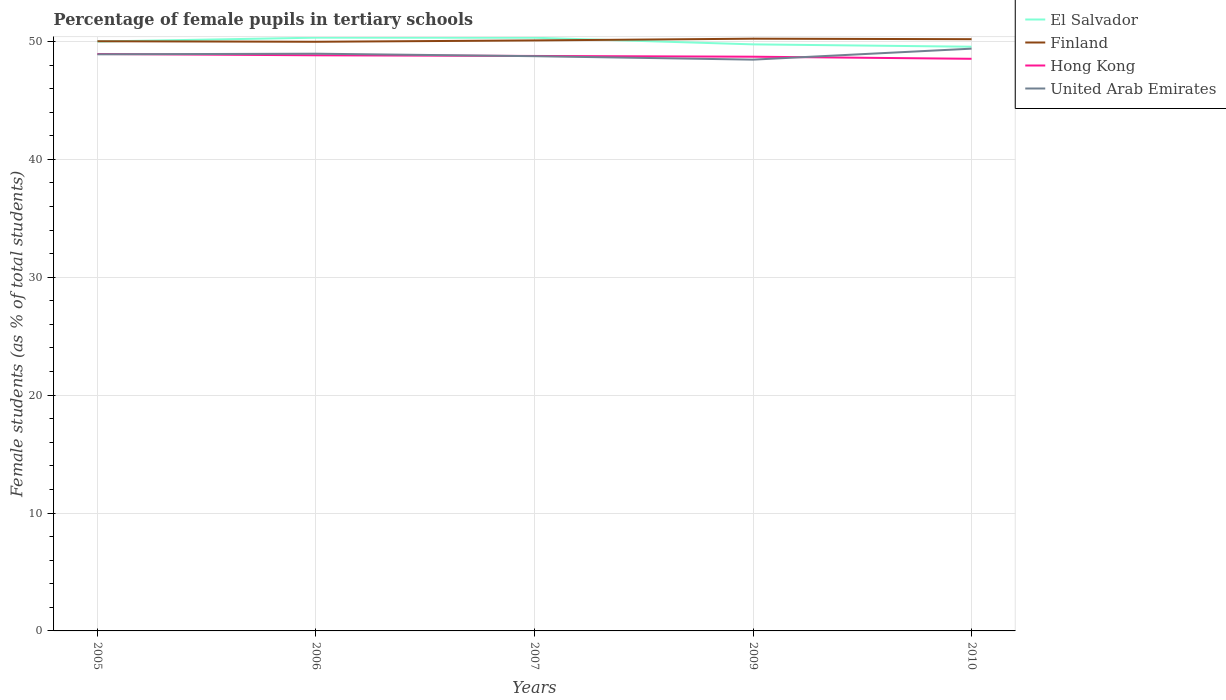Is the number of lines equal to the number of legend labels?
Offer a very short reply. Yes. Across all years, what is the maximum percentage of female pupils in tertiary schools in El Salvador?
Your answer should be very brief. 49.55. In which year was the percentage of female pupils in tertiary schools in Hong Kong maximum?
Offer a terse response. 2010. What is the total percentage of female pupils in tertiary schools in Hong Kong in the graph?
Ensure brevity in your answer.  0.41. What is the difference between the highest and the second highest percentage of female pupils in tertiary schools in Finland?
Your answer should be compact. 0.26. Is the percentage of female pupils in tertiary schools in United Arab Emirates strictly greater than the percentage of female pupils in tertiary schools in Finland over the years?
Ensure brevity in your answer.  Yes. How many lines are there?
Offer a very short reply. 4. What is the difference between two consecutive major ticks on the Y-axis?
Ensure brevity in your answer.  10. Are the values on the major ticks of Y-axis written in scientific E-notation?
Provide a short and direct response. No. How are the legend labels stacked?
Provide a short and direct response. Vertical. What is the title of the graph?
Make the answer very short. Percentage of female pupils in tertiary schools. Does "St. Kitts and Nevis" appear as one of the legend labels in the graph?
Provide a short and direct response. No. What is the label or title of the X-axis?
Your answer should be very brief. Years. What is the label or title of the Y-axis?
Make the answer very short. Female students (as % of total students). What is the Female students (as % of total students) of El Salvador in 2005?
Your answer should be very brief. 49.99. What is the Female students (as % of total students) of Finland in 2005?
Offer a terse response. 50.02. What is the Female students (as % of total students) of Hong Kong in 2005?
Keep it short and to the point. 48.94. What is the Female students (as % of total students) in United Arab Emirates in 2005?
Offer a terse response. 48.91. What is the Female students (as % of total students) in El Salvador in 2006?
Keep it short and to the point. 50.32. What is the Female students (as % of total students) in Finland in 2006?
Your answer should be very brief. 49.97. What is the Female students (as % of total students) in Hong Kong in 2006?
Offer a very short reply. 48.82. What is the Female students (as % of total students) in United Arab Emirates in 2006?
Your response must be concise. 48.96. What is the Female students (as % of total students) in El Salvador in 2007?
Your response must be concise. 50.31. What is the Female students (as % of total students) of Finland in 2007?
Make the answer very short. 50.09. What is the Female students (as % of total students) in Hong Kong in 2007?
Offer a terse response. 48.77. What is the Female students (as % of total students) of United Arab Emirates in 2007?
Offer a very short reply. 48.75. What is the Female students (as % of total students) of El Salvador in 2009?
Your answer should be compact. 49.75. What is the Female students (as % of total students) in Finland in 2009?
Your answer should be very brief. 50.23. What is the Female students (as % of total students) in Hong Kong in 2009?
Offer a very short reply. 48.71. What is the Female students (as % of total students) of United Arab Emirates in 2009?
Your response must be concise. 48.46. What is the Female students (as % of total students) in El Salvador in 2010?
Offer a terse response. 49.55. What is the Female students (as % of total students) of Finland in 2010?
Offer a terse response. 50.19. What is the Female students (as % of total students) in Hong Kong in 2010?
Provide a short and direct response. 48.53. What is the Female students (as % of total students) in United Arab Emirates in 2010?
Ensure brevity in your answer.  49.39. Across all years, what is the maximum Female students (as % of total students) in El Salvador?
Your answer should be very brief. 50.32. Across all years, what is the maximum Female students (as % of total students) in Finland?
Your answer should be compact. 50.23. Across all years, what is the maximum Female students (as % of total students) of Hong Kong?
Provide a short and direct response. 48.94. Across all years, what is the maximum Female students (as % of total students) in United Arab Emirates?
Keep it short and to the point. 49.39. Across all years, what is the minimum Female students (as % of total students) in El Salvador?
Your response must be concise. 49.55. Across all years, what is the minimum Female students (as % of total students) in Finland?
Provide a succinct answer. 49.97. Across all years, what is the minimum Female students (as % of total students) in Hong Kong?
Your response must be concise. 48.53. Across all years, what is the minimum Female students (as % of total students) of United Arab Emirates?
Your answer should be compact. 48.46. What is the total Female students (as % of total students) in El Salvador in the graph?
Your answer should be very brief. 249.93. What is the total Female students (as % of total students) in Finland in the graph?
Ensure brevity in your answer.  250.5. What is the total Female students (as % of total students) of Hong Kong in the graph?
Make the answer very short. 243.76. What is the total Female students (as % of total students) of United Arab Emirates in the graph?
Offer a terse response. 244.46. What is the difference between the Female students (as % of total students) of El Salvador in 2005 and that in 2006?
Your answer should be very brief. -0.33. What is the difference between the Female students (as % of total students) of Finland in 2005 and that in 2006?
Provide a short and direct response. 0.04. What is the difference between the Female students (as % of total students) of Hong Kong in 2005 and that in 2006?
Your response must be concise. 0.11. What is the difference between the Female students (as % of total students) of United Arab Emirates in 2005 and that in 2006?
Make the answer very short. -0.05. What is the difference between the Female students (as % of total students) in El Salvador in 2005 and that in 2007?
Provide a succinct answer. -0.32. What is the difference between the Female students (as % of total students) in Finland in 2005 and that in 2007?
Offer a terse response. -0.07. What is the difference between the Female students (as % of total students) of Hong Kong in 2005 and that in 2007?
Offer a terse response. 0.17. What is the difference between the Female students (as % of total students) of United Arab Emirates in 2005 and that in 2007?
Provide a short and direct response. 0.16. What is the difference between the Female students (as % of total students) in El Salvador in 2005 and that in 2009?
Your response must be concise. 0.24. What is the difference between the Female students (as % of total students) of Finland in 2005 and that in 2009?
Ensure brevity in your answer.  -0.22. What is the difference between the Female students (as % of total students) in Hong Kong in 2005 and that in 2009?
Make the answer very short. 0.23. What is the difference between the Female students (as % of total students) in United Arab Emirates in 2005 and that in 2009?
Provide a succinct answer. 0.45. What is the difference between the Female students (as % of total students) of El Salvador in 2005 and that in 2010?
Give a very brief answer. 0.44. What is the difference between the Female students (as % of total students) in Finland in 2005 and that in 2010?
Ensure brevity in your answer.  -0.17. What is the difference between the Female students (as % of total students) in Hong Kong in 2005 and that in 2010?
Make the answer very short. 0.41. What is the difference between the Female students (as % of total students) in United Arab Emirates in 2005 and that in 2010?
Offer a terse response. -0.48. What is the difference between the Female students (as % of total students) in El Salvador in 2006 and that in 2007?
Provide a short and direct response. 0.01. What is the difference between the Female students (as % of total students) in Finland in 2006 and that in 2007?
Ensure brevity in your answer.  -0.11. What is the difference between the Female students (as % of total students) of Hong Kong in 2006 and that in 2007?
Provide a short and direct response. 0.06. What is the difference between the Female students (as % of total students) of United Arab Emirates in 2006 and that in 2007?
Provide a succinct answer. 0.21. What is the difference between the Female students (as % of total students) in El Salvador in 2006 and that in 2009?
Offer a very short reply. 0.57. What is the difference between the Female students (as % of total students) of Finland in 2006 and that in 2009?
Your answer should be compact. -0.26. What is the difference between the Female students (as % of total students) in Hong Kong in 2006 and that in 2009?
Keep it short and to the point. 0.12. What is the difference between the Female students (as % of total students) of United Arab Emirates in 2006 and that in 2009?
Ensure brevity in your answer.  0.5. What is the difference between the Female students (as % of total students) in El Salvador in 2006 and that in 2010?
Your response must be concise. 0.77. What is the difference between the Female students (as % of total students) in Finland in 2006 and that in 2010?
Your answer should be very brief. -0.22. What is the difference between the Female students (as % of total students) in Hong Kong in 2006 and that in 2010?
Ensure brevity in your answer.  0.3. What is the difference between the Female students (as % of total students) of United Arab Emirates in 2006 and that in 2010?
Offer a very short reply. -0.43. What is the difference between the Female students (as % of total students) in El Salvador in 2007 and that in 2009?
Your response must be concise. 0.56. What is the difference between the Female students (as % of total students) in Finland in 2007 and that in 2009?
Ensure brevity in your answer.  -0.15. What is the difference between the Female students (as % of total students) in Hong Kong in 2007 and that in 2009?
Your response must be concise. 0.06. What is the difference between the Female students (as % of total students) of United Arab Emirates in 2007 and that in 2009?
Keep it short and to the point. 0.29. What is the difference between the Female students (as % of total students) of El Salvador in 2007 and that in 2010?
Offer a terse response. 0.76. What is the difference between the Female students (as % of total students) of Finland in 2007 and that in 2010?
Offer a very short reply. -0.1. What is the difference between the Female students (as % of total students) of Hong Kong in 2007 and that in 2010?
Give a very brief answer. 0.24. What is the difference between the Female students (as % of total students) in United Arab Emirates in 2007 and that in 2010?
Your answer should be compact. -0.64. What is the difference between the Female students (as % of total students) of El Salvador in 2009 and that in 2010?
Offer a very short reply. 0.2. What is the difference between the Female students (as % of total students) of Finland in 2009 and that in 2010?
Offer a terse response. 0.04. What is the difference between the Female students (as % of total students) of Hong Kong in 2009 and that in 2010?
Your answer should be very brief. 0.18. What is the difference between the Female students (as % of total students) in United Arab Emirates in 2009 and that in 2010?
Your answer should be very brief. -0.93. What is the difference between the Female students (as % of total students) of El Salvador in 2005 and the Female students (as % of total students) of Finland in 2006?
Provide a short and direct response. 0.02. What is the difference between the Female students (as % of total students) of El Salvador in 2005 and the Female students (as % of total students) of Hong Kong in 2006?
Your answer should be very brief. 1.17. What is the difference between the Female students (as % of total students) of El Salvador in 2005 and the Female students (as % of total students) of United Arab Emirates in 2006?
Provide a succinct answer. 1.03. What is the difference between the Female students (as % of total students) in Finland in 2005 and the Female students (as % of total students) in Hong Kong in 2006?
Keep it short and to the point. 1.19. What is the difference between the Female students (as % of total students) in Finland in 2005 and the Female students (as % of total students) in United Arab Emirates in 2006?
Provide a short and direct response. 1.06. What is the difference between the Female students (as % of total students) in Hong Kong in 2005 and the Female students (as % of total students) in United Arab Emirates in 2006?
Make the answer very short. -0.02. What is the difference between the Female students (as % of total students) in El Salvador in 2005 and the Female students (as % of total students) in Finland in 2007?
Ensure brevity in your answer.  -0.09. What is the difference between the Female students (as % of total students) in El Salvador in 2005 and the Female students (as % of total students) in Hong Kong in 2007?
Your answer should be compact. 1.22. What is the difference between the Female students (as % of total students) of El Salvador in 2005 and the Female students (as % of total students) of United Arab Emirates in 2007?
Keep it short and to the point. 1.24. What is the difference between the Female students (as % of total students) in Finland in 2005 and the Female students (as % of total students) in Hong Kong in 2007?
Make the answer very short. 1.25. What is the difference between the Female students (as % of total students) of Finland in 2005 and the Female students (as % of total students) of United Arab Emirates in 2007?
Provide a short and direct response. 1.27. What is the difference between the Female students (as % of total students) in Hong Kong in 2005 and the Female students (as % of total students) in United Arab Emirates in 2007?
Make the answer very short. 0.19. What is the difference between the Female students (as % of total students) of El Salvador in 2005 and the Female students (as % of total students) of Finland in 2009?
Provide a succinct answer. -0.24. What is the difference between the Female students (as % of total students) in El Salvador in 2005 and the Female students (as % of total students) in Hong Kong in 2009?
Your response must be concise. 1.29. What is the difference between the Female students (as % of total students) in El Salvador in 2005 and the Female students (as % of total students) in United Arab Emirates in 2009?
Offer a terse response. 1.54. What is the difference between the Female students (as % of total students) in Finland in 2005 and the Female students (as % of total students) in Hong Kong in 2009?
Make the answer very short. 1.31. What is the difference between the Female students (as % of total students) of Finland in 2005 and the Female students (as % of total students) of United Arab Emirates in 2009?
Provide a short and direct response. 1.56. What is the difference between the Female students (as % of total students) in Hong Kong in 2005 and the Female students (as % of total students) in United Arab Emirates in 2009?
Your answer should be compact. 0.48. What is the difference between the Female students (as % of total students) of El Salvador in 2005 and the Female students (as % of total students) of Finland in 2010?
Offer a terse response. -0.2. What is the difference between the Female students (as % of total students) of El Salvador in 2005 and the Female students (as % of total students) of Hong Kong in 2010?
Provide a succinct answer. 1.46. What is the difference between the Female students (as % of total students) of El Salvador in 2005 and the Female students (as % of total students) of United Arab Emirates in 2010?
Make the answer very short. 0.6. What is the difference between the Female students (as % of total students) in Finland in 2005 and the Female students (as % of total students) in Hong Kong in 2010?
Make the answer very short. 1.49. What is the difference between the Female students (as % of total students) of Finland in 2005 and the Female students (as % of total students) of United Arab Emirates in 2010?
Offer a terse response. 0.63. What is the difference between the Female students (as % of total students) in Hong Kong in 2005 and the Female students (as % of total students) in United Arab Emirates in 2010?
Give a very brief answer. -0.45. What is the difference between the Female students (as % of total students) of El Salvador in 2006 and the Female students (as % of total students) of Finland in 2007?
Your answer should be very brief. 0.23. What is the difference between the Female students (as % of total students) of El Salvador in 2006 and the Female students (as % of total students) of Hong Kong in 2007?
Give a very brief answer. 1.55. What is the difference between the Female students (as % of total students) in El Salvador in 2006 and the Female students (as % of total students) in United Arab Emirates in 2007?
Your response must be concise. 1.57. What is the difference between the Female students (as % of total students) in Finland in 2006 and the Female students (as % of total students) in Hong Kong in 2007?
Give a very brief answer. 1.2. What is the difference between the Female students (as % of total students) of Finland in 2006 and the Female students (as % of total students) of United Arab Emirates in 2007?
Your answer should be compact. 1.22. What is the difference between the Female students (as % of total students) of Hong Kong in 2006 and the Female students (as % of total students) of United Arab Emirates in 2007?
Give a very brief answer. 0.08. What is the difference between the Female students (as % of total students) of El Salvador in 2006 and the Female students (as % of total students) of Finland in 2009?
Make the answer very short. 0.09. What is the difference between the Female students (as % of total students) in El Salvador in 2006 and the Female students (as % of total students) in Hong Kong in 2009?
Your response must be concise. 1.61. What is the difference between the Female students (as % of total students) in El Salvador in 2006 and the Female students (as % of total students) in United Arab Emirates in 2009?
Offer a terse response. 1.86. What is the difference between the Female students (as % of total students) of Finland in 2006 and the Female students (as % of total students) of Hong Kong in 2009?
Provide a succinct answer. 1.27. What is the difference between the Female students (as % of total students) in Finland in 2006 and the Female students (as % of total students) in United Arab Emirates in 2009?
Offer a very short reply. 1.52. What is the difference between the Female students (as % of total students) in Hong Kong in 2006 and the Female students (as % of total students) in United Arab Emirates in 2009?
Give a very brief answer. 0.37. What is the difference between the Female students (as % of total students) in El Salvador in 2006 and the Female students (as % of total students) in Finland in 2010?
Your response must be concise. 0.13. What is the difference between the Female students (as % of total students) in El Salvador in 2006 and the Female students (as % of total students) in Hong Kong in 2010?
Provide a short and direct response. 1.79. What is the difference between the Female students (as % of total students) of El Salvador in 2006 and the Female students (as % of total students) of United Arab Emirates in 2010?
Your response must be concise. 0.93. What is the difference between the Female students (as % of total students) in Finland in 2006 and the Female students (as % of total students) in Hong Kong in 2010?
Offer a terse response. 1.44. What is the difference between the Female students (as % of total students) of Finland in 2006 and the Female students (as % of total students) of United Arab Emirates in 2010?
Offer a very short reply. 0.58. What is the difference between the Female students (as % of total students) of Hong Kong in 2006 and the Female students (as % of total students) of United Arab Emirates in 2010?
Your answer should be compact. -0.56. What is the difference between the Female students (as % of total students) in El Salvador in 2007 and the Female students (as % of total students) in Finland in 2009?
Your answer should be very brief. 0.08. What is the difference between the Female students (as % of total students) of El Salvador in 2007 and the Female students (as % of total students) of Hong Kong in 2009?
Keep it short and to the point. 1.61. What is the difference between the Female students (as % of total students) of El Salvador in 2007 and the Female students (as % of total students) of United Arab Emirates in 2009?
Provide a succinct answer. 1.86. What is the difference between the Female students (as % of total students) in Finland in 2007 and the Female students (as % of total students) in Hong Kong in 2009?
Ensure brevity in your answer.  1.38. What is the difference between the Female students (as % of total students) of Finland in 2007 and the Female students (as % of total students) of United Arab Emirates in 2009?
Your answer should be compact. 1.63. What is the difference between the Female students (as % of total students) in Hong Kong in 2007 and the Female students (as % of total students) in United Arab Emirates in 2009?
Give a very brief answer. 0.31. What is the difference between the Female students (as % of total students) in El Salvador in 2007 and the Female students (as % of total students) in Finland in 2010?
Offer a very short reply. 0.12. What is the difference between the Female students (as % of total students) in El Salvador in 2007 and the Female students (as % of total students) in Hong Kong in 2010?
Ensure brevity in your answer.  1.79. What is the difference between the Female students (as % of total students) in El Salvador in 2007 and the Female students (as % of total students) in United Arab Emirates in 2010?
Provide a succinct answer. 0.93. What is the difference between the Female students (as % of total students) of Finland in 2007 and the Female students (as % of total students) of Hong Kong in 2010?
Offer a very short reply. 1.56. What is the difference between the Female students (as % of total students) in Finland in 2007 and the Female students (as % of total students) in United Arab Emirates in 2010?
Ensure brevity in your answer.  0.7. What is the difference between the Female students (as % of total students) in Hong Kong in 2007 and the Female students (as % of total students) in United Arab Emirates in 2010?
Keep it short and to the point. -0.62. What is the difference between the Female students (as % of total students) in El Salvador in 2009 and the Female students (as % of total students) in Finland in 2010?
Your answer should be compact. -0.44. What is the difference between the Female students (as % of total students) of El Salvador in 2009 and the Female students (as % of total students) of Hong Kong in 2010?
Offer a very short reply. 1.22. What is the difference between the Female students (as % of total students) in El Salvador in 2009 and the Female students (as % of total students) in United Arab Emirates in 2010?
Offer a terse response. 0.36. What is the difference between the Female students (as % of total students) of Finland in 2009 and the Female students (as % of total students) of Hong Kong in 2010?
Provide a short and direct response. 1.71. What is the difference between the Female students (as % of total students) of Finland in 2009 and the Female students (as % of total students) of United Arab Emirates in 2010?
Your answer should be compact. 0.85. What is the difference between the Female students (as % of total students) of Hong Kong in 2009 and the Female students (as % of total students) of United Arab Emirates in 2010?
Offer a terse response. -0.68. What is the average Female students (as % of total students) of El Salvador per year?
Give a very brief answer. 49.99. What is the average Female students (as % of total students) of Finland per year?
Ensure brevity in your answer.  50.1. What is the average Female students (as % of total students) in Hong Kong per year?
Your response must be concise. 48.75. What is the average Female students (as % of total students) in United Arab Emirates per year?
Keep it short and to the point. 48.89. In the year 2005, what is the difference between the Female students (as % of total students) of El Salvador and Female students (as % of total students) of Finland?
Provide a short and direct response. -0.02. In the year 2005, what is the difference between the Female students (as % of total students) of El Salvador and Female students (as % of total students) of Hong Kong?
Ensure brevity in your answer.  1.06. In the year 2005, what is the difference between the Female students (as % of total students) in El Salvador and Female students (as % of total students) in United Arab Emirates?
Provide a succinct answer. 1.08. In the year 2005, what is the difference between the Female students (as % of total students) in Finland and Female students (as % of total students) in Hong Kong?
Offer a terse response. 1.08. In the year 2005, what is the difference between the Female students (as % of total students) in Finland and Female students (as % of total students) in United Arab Emirates?
Ensure brevity in your answer.  1.11. In the year 2005, what is the difference between the Female students (as % of total students) of Hong Kong and Female students (as % of total students) of United Arab Emirates?
Ensure brevity in your answer.  0.03. In the year 2006, what is the difference between the Female students (as % of total students) in El Salvador and Female students (as % of total students) in Finland?
Give a very brief answer. 0.35. In the year 2006, what is the difference between the Female students (as % of total students) in El Salvador and Female students (as % of total students) in Hong Kong?
Make the answer very short. 1.49. In the year 2006, what is the difference between the Female students (as % of total students) of El Salvador and Female students (as % of total students) of United Arab Emirates?
Make the answer very short. 1.36. In the year 2006, what is the difference between the Female students (as % of total students) of Finland and Female students (as % of total students) of Hong Kong?
Make the answer very short. 1.15. In the year 2006, what is the difference between the Female students (as % of total students) of Finland and Female students (as % of total students) of United Arab Emirates?
Provide a short and direct response. 1.01. In the year 2006, what is the difference between the Female students (as % of total students) of Hong Kong and Female students (as % of total students) of United Arab Emirates?
Offer a very short reply. -0.13. In the year 2007, what is the difference between the Female students (as % of total students) of El Salvador and Female students (as % of total students) of Finland?
Provide a short and direct response. 0.23. In the year 2007, what is the difference between the Female students (as % of total students) of El Salvador and Female students (as % of total students) of Hong Kong?
Offer a very short reply. 1.54. In the year 2007, what is the difference between the Female students (as % of total students) of El Salvador and Female students (as % of total students) of United Arab Emirates?
Offer a terse response. 1.56. In the year 2007, what is the difference between the Female students (as % of total students) of Finland and Female students (as % of total students) of Hong Kong?
Give a very brief answer. 1.32. In the year 2007, what is the difference between the Female students (as % of total students) of Finland and Female students (as % of total students) of United Arab Emirates?
Provide a short and direct response. 1.34. In the year 2007, what is the difference between the Female students (as % of total students) of Hong Kong and Female students (as % of total students) of United Arab Emirates?
Provide a succinct answer. 0.02. In the year 2009, what is the difference between the Female students (as % of total students) of El Salvador and Female students (as % of total students) of Finland?
Offer a very short reply. -0.48. In the year 2009, what is the difference between the Female students (as % of total students) in El Salvador and Female students (as % of total students) in Hong Kong?
Keep it short and to the point. 1.05. In the year 2009, what is the difference between the Female students (as % of total students) of El Salvador and Female students (as % of total students) of United Arab Emirates?
Make the answer very short. 1.3. In the year 2009, what is the difference between the Female students (as % of total students) in Finland and Female students (as % of total students) in Hong Kong?
Keep it short and to the point. 1.53. In the year 2009, what is the difference between the Female students (as % of total students) in Finland and Female students (as % of total students) in United Arab Emirates?
Offer a terse response. 1.78. In the year 2009, what is the difference between the Female students (as % of total students) of Hong Kong and Female students (as % of total students) of United Arab Emirates?
Your response must be concise. 0.25. In the year 2010, what is the difference between the Female students (as % of total students) in El Salvador and Female students (as % of total students) in Finland?
Your answer should be compact. -0.64. In the year 2010, what is the difference between the Female students (as % of total students) of El Salvador and Female students (as % of total students) of Hong Kong?
Offer a terse response. 1.02. In the year 2010, what is the difference between the Female students (as % of total students) of El Salvador and Female students (as % of total students) of United Arab Emirates?
Your answer should be very brief. 0.16. In the year 2010, what is the difference between the Female students (as % of total students) in Finland and Female students (as % of total students) in Hong Kong?
Offer a terse response. 1.66. In the year 2010, what is the difference between the Female students (as % of total students) of Finland and Female students (as % of total students) of United Arab Emirates?
Your response must be concise. 0.8. In the year 2010, what is the difference between the Female students (as % of total students) of Hong Kong and Female students (as % of total students) of United Arab Emirates?
Provide a succinct answer. -0.86. What is the ratio of the Female students (as % of total students) in Hong Kong in 2005 to that in 2006?
Your answer should be very brief. 1. What is the ratio of the Female students (as % of total students) of El Salvador in 2005 to that in 2007?
Ensure brevity in your answer.  0.99. What is the ratio of the Female students (as % of total students) of Hong Kong in 2005 to that in 2007?
Provide a short and direct response. 1. What is the ratio of the Female students (as % of total students) of United Arab Emirates in 2005 to that in 2007?
Your answer should be compact. 1. What is the ratio of the Female students (as % of total students) in El Salvador in 2005 to that in 2009?
Provide a short and direct response. 1. What is the ratio of the Female students (as % of total students) of Hong Kong in 2005 to that in 2009?
Offer a terse response. 1. What is the ratio of the Female students (as % of total students) in United Arab Emirates in 2005 to that in 2009?
Keep it short and to the point. 1.01. What is the ratio of the Female students (as % of total students) in El Salvador in 2005 to that in 2010?
Offer a very short reply. 1.01. What is the ratio of the Female students (as % of total students) of Finland in 2005 to that in 2010?
Ensure brevity in your answer.  1. What is the ratio of the Female students (as % of total students) in Hong Kong in 2005 to that in 2010?
Your answer should be very brief. 1.01. What is the ratio of the Female students (as % of total students) in United Arab Emirates in 2005 to that in 2010?
Make the answer very short. 0.99. What is the ratio of the Female students (as % of total students) in El Salvador in 2006 to that in 2007?
Provide a short and direct response. 1. What is the ratio of the Female students (as % of total students) in Finland in 2006 to that in 2007?
Provide a succinct answer. 1. What is the ratio of the Female students (as % of total students) of El Salvador in 2006 to that in 2009?
Make the answer very short. 1.01. What is the ratio of the Female students (as % of total students) in Hong Kong in 2006 to that in 2009?
Keep it short and to the point. 1. What is the ratio of the Female students (as % of total students) in United Arab Emirates in 2006 to that in 2009?
Offer a terse response. 1.01. What is the ratio of the Female students (as % of total students) of El Salvador in 2006 to that in 2010?
Keep it short and to the point. 1.02. What is the ratio of the Female students (as % of total students) of Finland in 2006 to that in 2010?
Provide a short and direct response. 1. What is the ratio of the Female students (as % of total students) of Hong Kong in 2006 to that in 2010?
Your response must be concise. 1.01. What is the ratio of the Female students (as % of total students) of El Salvador in 2007 to that in 2009?
Ensure brevity in your answer.  1.01. What is the ratio of the Female students (as % of total students) of Finland in 2007 to that in 2009?
Provide a short and direct response. 1. What is the ratio of the Female students (as % of total students) in El Salvador in 2007 to that in 2010?
Your answer should be very brief. 1.02. What is the ratio of the Female students (as % of total students) of Finland in 2007 to that in 2010?
Give a very brief answer. 1. What is the ratio of the Female students (as % of total students) of United Arab Emirates in 2007 to that in 2010?
Ensure brevity in your answer.  0.99. What is the ratio of the Female students (as % of total students) in Finland in 2009 to that in 2010?
Your response must be concise. 1. What is the ratio of the Female students (as % of total students) of Hong Kong in 2009 to that in 2010?
Provide a short and direct response. 1. What is the ratio of the Female students (as % of total students) in United Arab Emirates in 2009 to that in 2010?
Ensure brevity in your answer.  0.98. What is the difference between the highest and the second highest Female students (as % of total students) in El Salvador?
Make the answer very short. 0.01. What is the difference between the highest and the second highest Female students (as % of total students) in Finland?
Your answer should be compact. 0.04. What is the difference between the highest and the second highest Female students (as % of total students) of Hong Kong?
Provide a succinct answer. 0.11. What is the difference between the highest and the second highest Female students (as % of total students) in United Arab Emirates?
Offer a terse response. 0.43. What is the difference between the highest and the lowest Female students (as % of total students) of El Salvador?
Your answer should be compact. 0.77. What is the difference between the highest and the lowest Female students (as % of total students) in Finland?
Your response must be concise. 0.26. What is the difference between the highest and the lowest Female students (as % of total students) of Hong Kong?
Provide a succinct answer. 0.41. What is the difference between the highest and the lowest Female students (as % of total students) in United Arab Emirates?
Give a very brief answer. 0.93. 